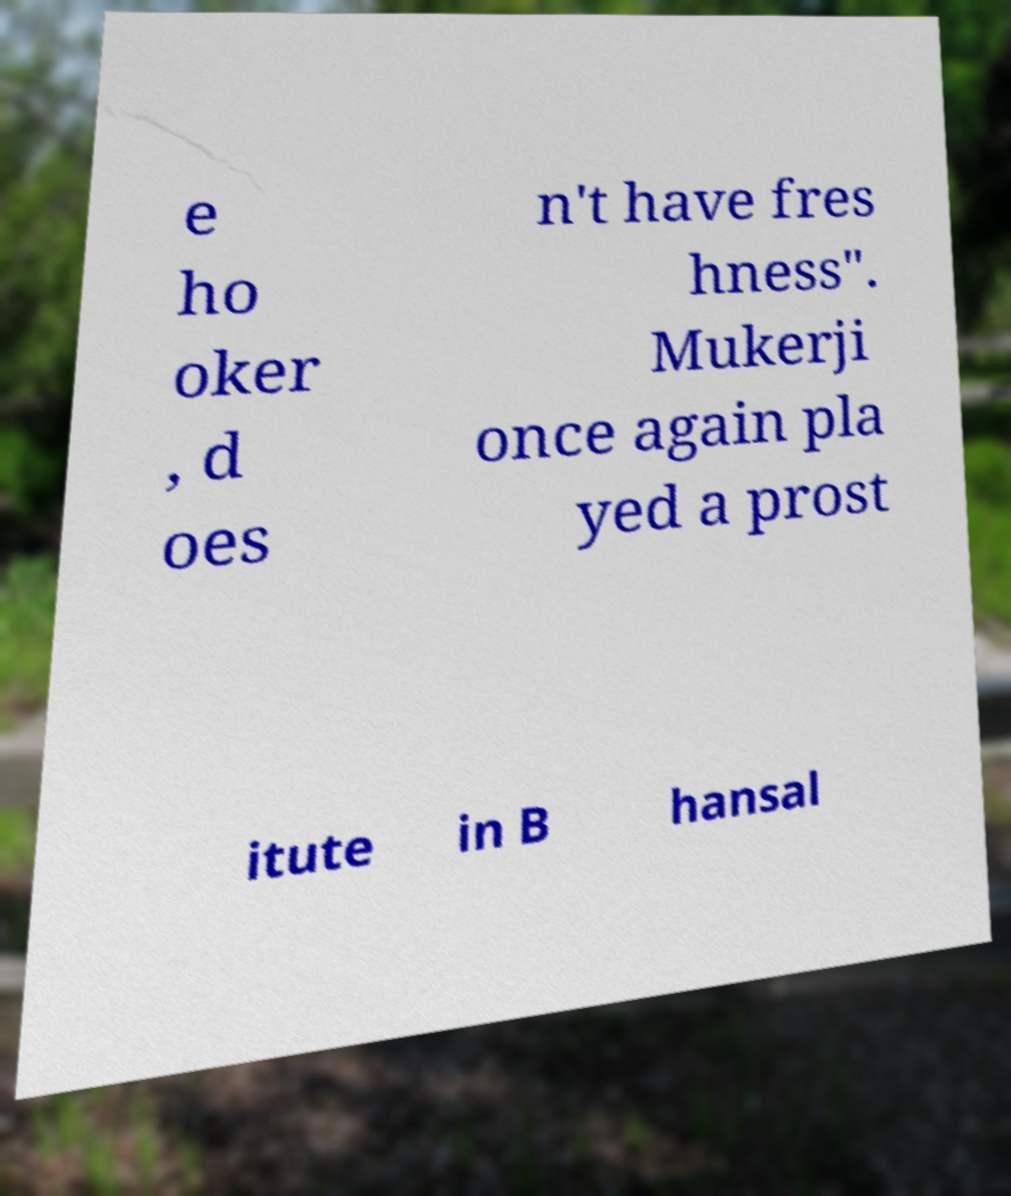For documentation purposes, I need the text within this image transcribed. Could you provide that? e ho oker , d oes n't have fres hness". Mukerji once again pla yed a prost itute in B hansal 